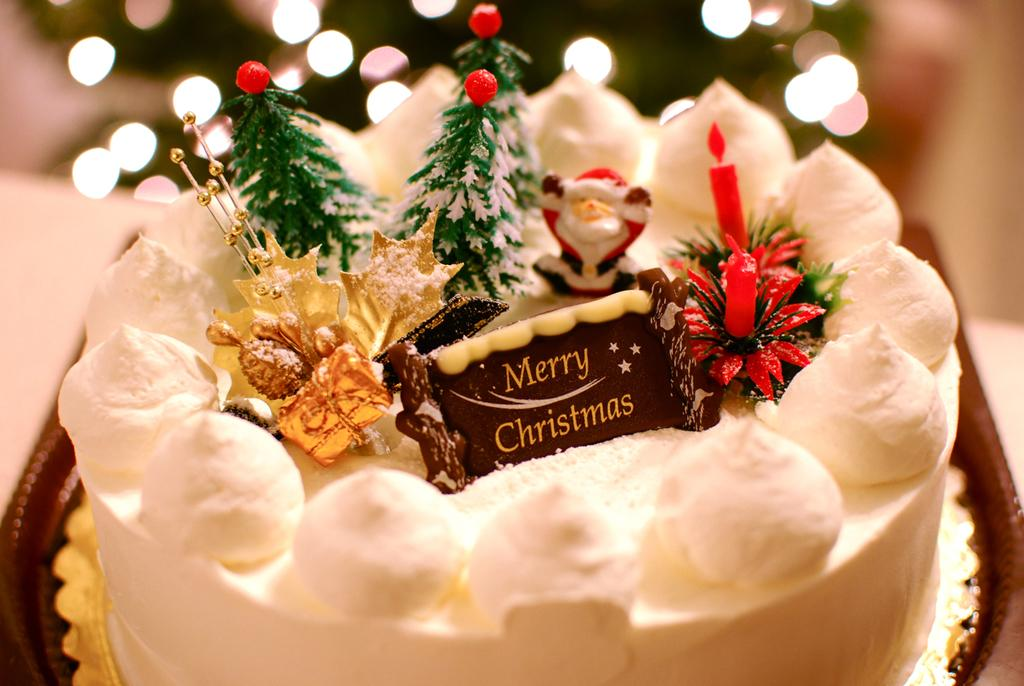What is the main subject of the image? There is a cake in the image. Where is the cake located? The cake is placed on a table. What type of glue is being used to hold the cake together in the image? There is no glue present in the image, and the cake does not need to be held together. 